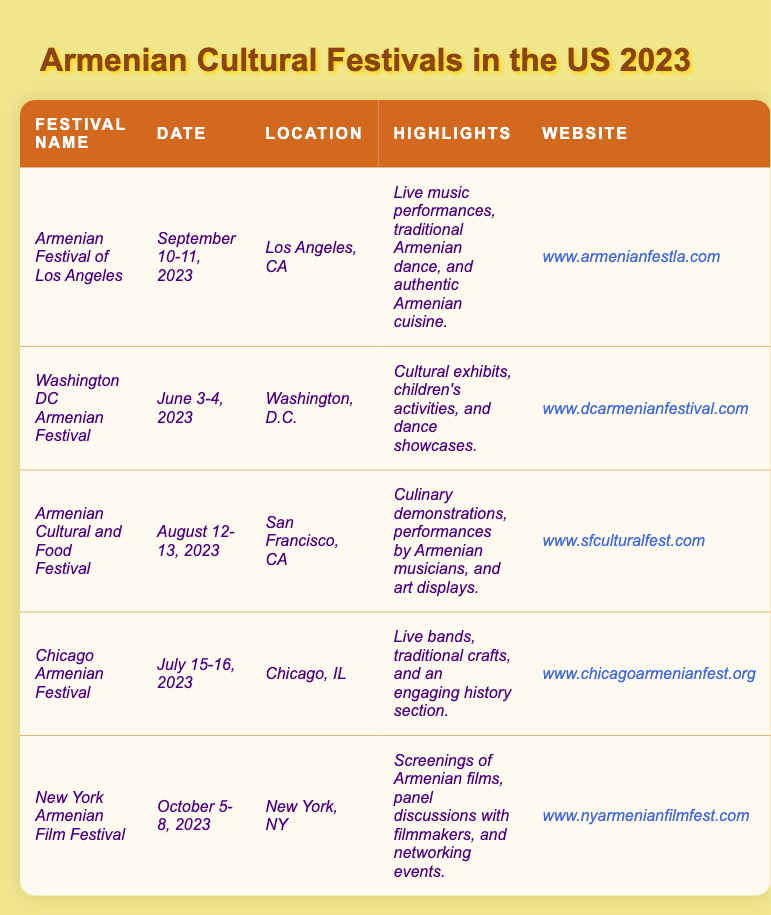What is the date of the Armenian Festival of Los Angeles? The table lists the Armenian Festival of Los Angeles under the “Date” column as “September 10-11, 2023.”
Answer: September 10-11, 2023 How many festivals are scheduled to take place in September 2023? The table indicates only one festival, the Armenian Festival of Los Angeles, listed for September.
Answer: One Which festival features culinary demonstrations? The table lists the Armenian Cultural and Food Festival under the "Highlights" column mentioning "culinary demonstrations."
Answer: Armenian Cultural and Food Festival Which festival takes place in New York? The table shows that the New York Armenian Film Festival is listed under the “Location” column as held in New York, NY.
Answer: New York Armenian Film Festival Is there a festival dedicated to film? The table indicates that the New York Armenian Film Festival is focused on screenings of Armenian films, confirming that there is a film festival.
Answer: Yes How many festivals are held in June and July combined? The Washington DC Armenian Festival is in June, and the Chicago Armenian Festival is in July. Adding these gives 2 festivals in total for June and July.
Answer: Two What are the highlights of the festival happening in San Francisco? The Armenian Cultural and Food Festival according to the table has highlights that include "culinary demonstrations, performances by Armenian musicians, and art displays."
Answer: Culinary demonstrations, performances by Armenian musicians, and art displays Which festival is the latest in the year among these listings? The New York Armenian Film Festival is scheduled for October 5-8, 2023, which is the latest date when comparing all the festivals in the table.
Answer: New York Armenian Film Festival What is the common feature between the Chicago and Los Angeles festivals? Both the Chicago Armenian Festival and the Armenian Festival of Los Angeles include live music performances as mentioned in their highlights sections in the table.
Answer: Live music performances If someone wanted to attend a festival that includes children's activities, which one should they choose? The table identifies the Washington DC Armenian Festival as including "children's activities" in its highlights, making it the right choice for that option.
Answer: Washington DC Armenian Festival 